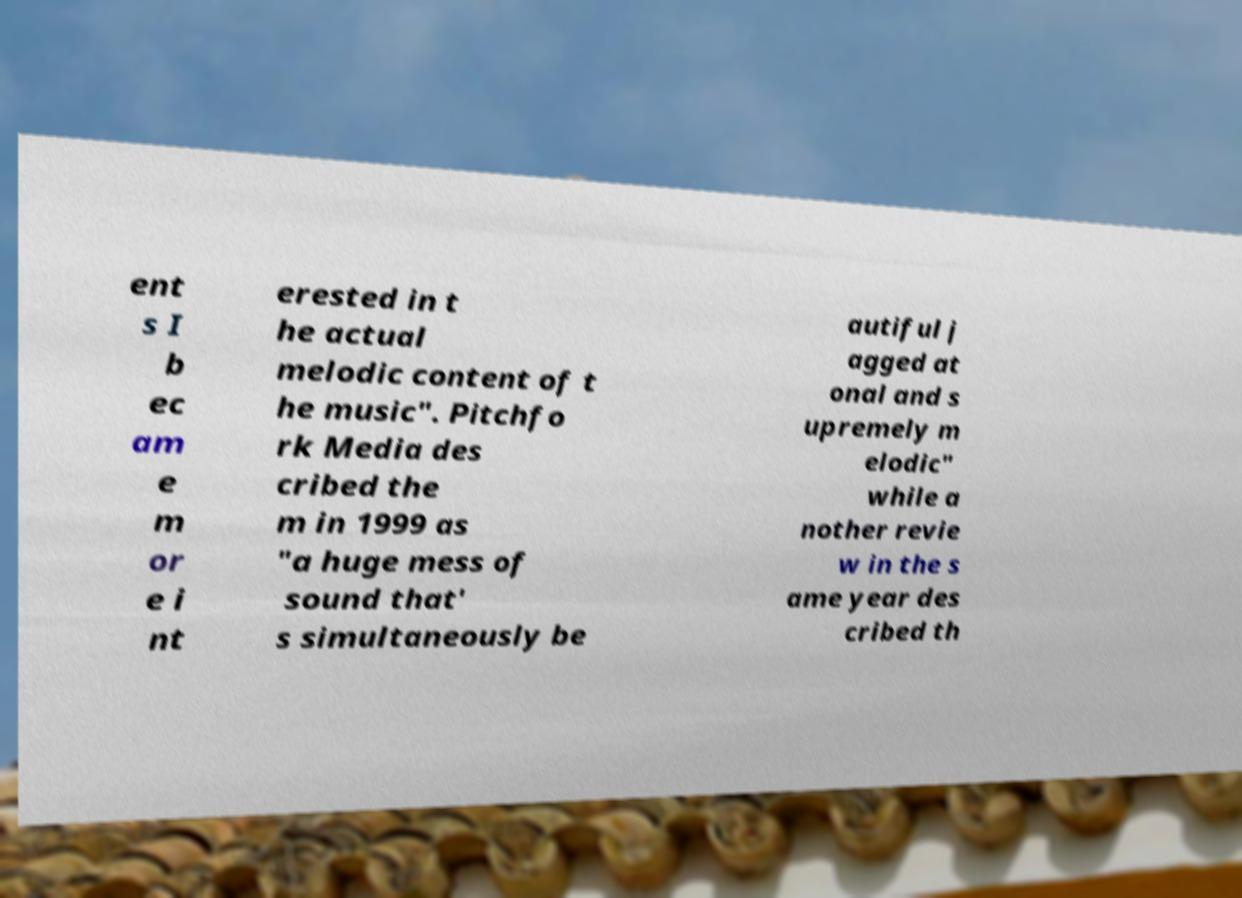What messages or text are displayed in this image? I need them in a readable, typed format. ent s I b ec am e m or e i nt erested in t he actual melodic content of t he music". Pitchfo rk Media des cribed the m in 1999 as "a huge mess of sound that' s simultaneously be autiful j agged at onal and s upremely m elodic" while a nother revie w in the s ame year des cribed th 